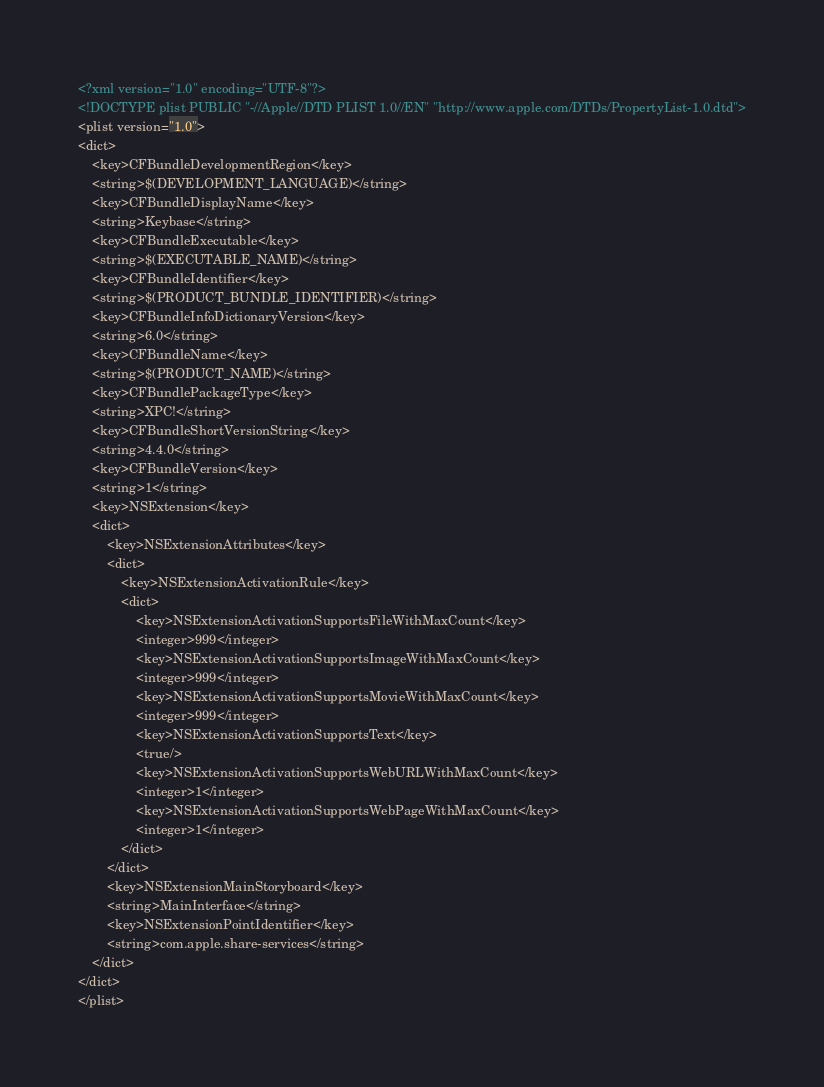<code> <loc_0><loc_0><loc_500><loc_500><_XML_><?xml version="1.0" encoding="UTF-8"?>
<!DOCTYPE plist PUBLIC "-//Apple//DTD PLIST 1.0//EN" "http://www.apple.com/DTDs/PropertyList-1.0.dtd">
<plist version="1.0">
<dict>
	<key>CFBundleDevelopmentRegion</key>
	<string>$(DEVELOPMENT_LANGUAGE)</string>
	<key>CFBundleDisplayName</key>
	<string>Keybase</string>
	<key>CFBundleExecutable</key>
	<string>$(EXECUTABLE_NAME)</string>
	<key>CFBundleIdentifier</key>
	<string>$(PRODUCT_BUNDLE_IDENTIFIER)</string>
	<key>CFBundleInfoDictionaryVersion</key>
	<string>6.0</string>
	<key>CFBundleName</key>
	<string>$(PRODUCT_NAME)</string>
	<key>CFBundlePackageType</key>
	<string>XPC!</string>
	<key>CFBundleShortVersionString</key>
	<string>4.4.0</string>
	<key>CFBundleVersion</key>
	<string>1</string>
	<key>NSExtension</key>
	<dict>
		<key>NSExtensionAttributes</key>
		<dict>
			<key>NSExtensionActivationRule</key>
			<dict>
				<key>NSExtensionActivationSupportsFileWithMaxCount</key>
				<integer>999</integer>
				<key>NSExtensionActivationSupportsImageWithMaxCount</key>
				<integer>999</integer>
				<key>NSExtensionActivationSupportsMovieWithMaxCount</key>
				<integer>999</integer>
				<key>NSExtensionActivationSupportsText</key>
				<true/>
				<key>NSExtensionActivationSupportsWebURLWithMaxCount</key>
				<integer>1</integer>
				<key>NSExtensionActivationSupportsWebPageWithMaxCount</key>
				<integer>1</integer>
			</dict>
		</dict>
		<key>NSExtensionMainStoryboard</key>
		<string>MainInterface</string>
		<key>NSExtensionPointIdentifier</key>
		<string>com.apple.share-services</string>
	</dict>
</dict>
</plist>
</code> 